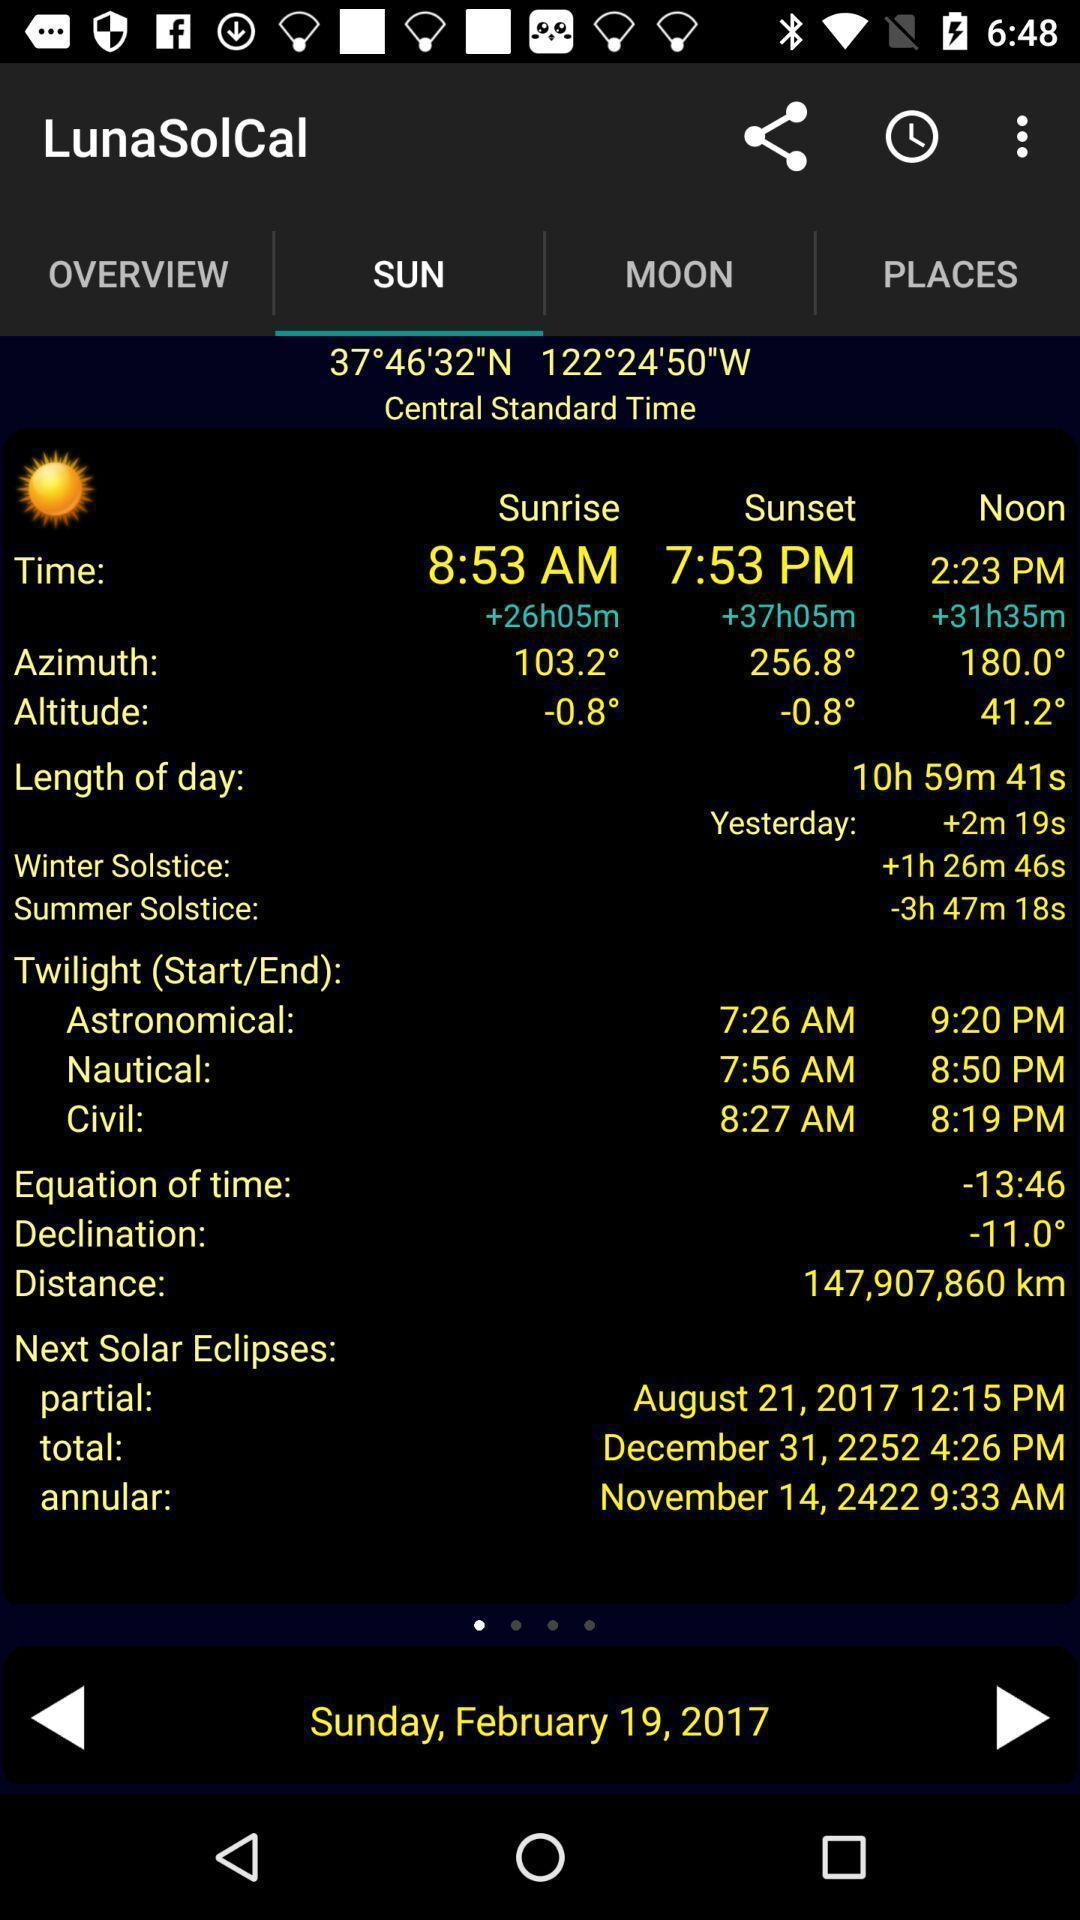Give me a summary of this screen capture. Page displaying weather forecast for an app. 